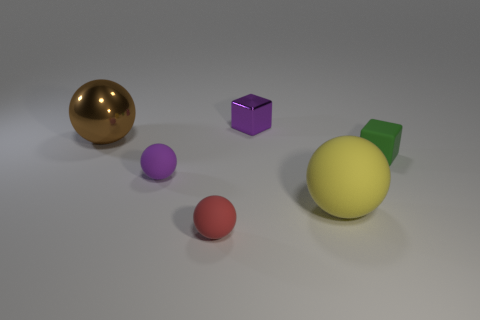Subtract all brown spheres. How many spheres are left? 3 Subtract all purple spheres. How many spheres are left? 3 Subtract all gray balls. Subtract all brown cylinders. How many balls are left? 4 Add 4 large shiny spheres. How many objects exist? 10 Subtract all blocks. How many objects are left? 4 Subtract 0 blue cylinders. How many objects are left? 6 Subtract all big yellow matte objects. Subtract all small cyan metallic cylinders. How many objects are left? 5 Add 5 tiny purple cubes. How many tiny purple cubes are left? 6 Add 5 purple metal cubes. How many purple metal cubes exist? 6 